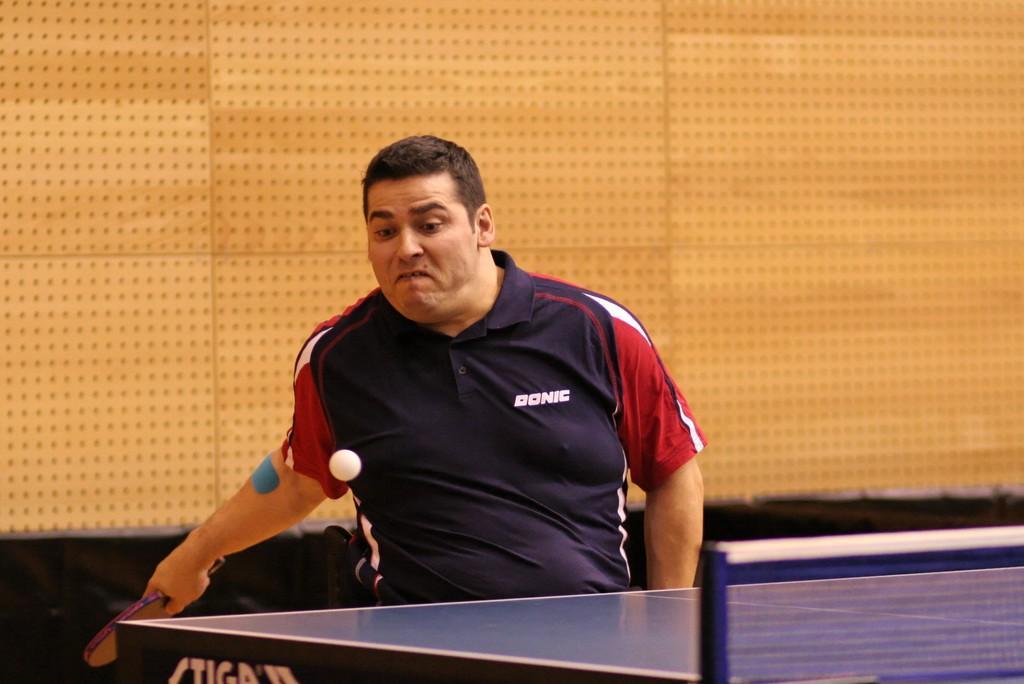How would you summarize this image in a sentence or two? The person wearing blue shirt is playing table tennis. 